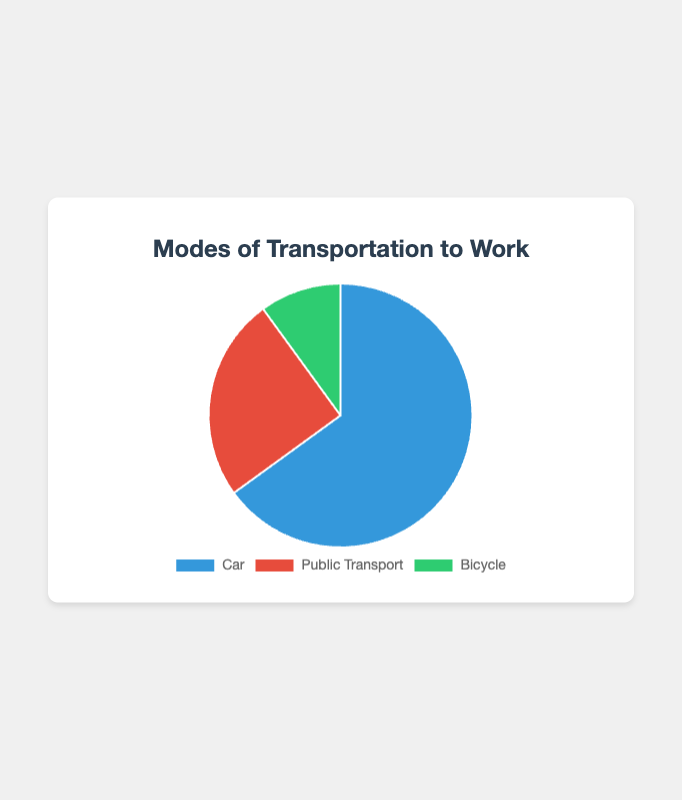what is the most commonly used mode of transportation to work? The pie chart shows three modes of transportation with their corresponding percentages. The segment representing "Car" is the largest, indicating that 65% of people use cars to get to work.
Answer: Car Which mode of transportation has the smallest percentage of users? The pie chart displays three segments with different colors and sizes. The smallest segment, representing 10%, is for "Bicycle."
Answer: Bicycle How much larger is the percentage of people using cars than those using public transport? The percentage of people using cars is 65%, and the percentage for public transport is 25%. The difference is calculated as 65% - 25% = 40%.
Answer: 40% If you combine the percentages of people using public transport and bicycles, does it exceed the percentage of people using cars? The percentage for public transport is 25%, and for bicycles, it is 10%. The combined percentage is 25% + 10% = 35%. This is less than the 65% for cars.
Answer: No Among cars, public transport, and bicycles, which two modes of transportation have equal percentages in any city? For the cities Los Angeles, New York, Chicago, Houston, and Phoenix, there is no mode of transportation where the percentages are equal between any two modes.
Answer: None What color represents public transport in the pie chart? The pie chart uses distinct colors for each segment. The segment for public transport is colored in red.
Answer: Red What is the difference in percentage between the least and most used modes of transportation? The most used mode is "Car" at 65%, and the least used is "Bicycle" at 10%. The difference is 65% - 10% = 55%.
Answer: 55% Which city has the highest percentage of people using cars? According to the data, Los Angeles has the highest percentage of people using cars, which is 80%.
Answer: Los Angeles Given the data, which city has the closest percentage of car users to the overall percentage for cars? The overall percentage for cars is 65%. Among the cities listed, Phoenix also has 65%, matching the overall percentage exactly.
Answer: Phoenix 